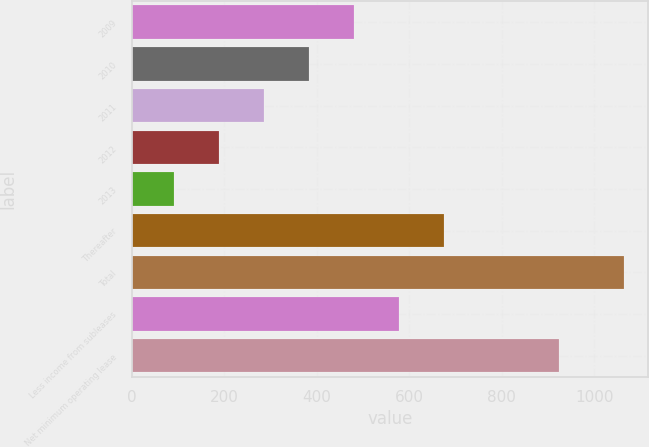Convert chart. <chart><loc_0><loc_0><loc_500><loc_500><bar_chart><fcel>2009<fcel>2010<fcel>2011<fcel>2012<fcel>2013<fcel>Thereafter<fcel>Total<fcel>Less income from subleases<fcel>Net minimum operating lease<nl><fcel>480.2<fcel>382.9<fcel>285.6<fcel>188.3<fcel>91<fcel>674.8<fcel>1064<fcel>577.5<fcel>924<nl></chart> 